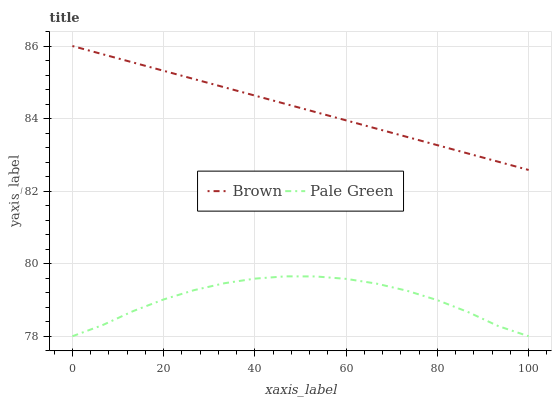Does Pale Green have the minimum area under the curve?
Answer yes or no. Yes. Does Brown have the maximum area under the curve?
Answer yes or no. Yes. Does Pale Green have the maximum area under the curve?
Answer yes or no. No. Is Brown the smoothest?
Answer yes or no. Yes. Is Pale Green the roughest?
Answer yes or no. Yes. Is Pale Green the smoothest?
Answer yes or no. No. Does Pale Green have the lowest value?
Answer yes or no. Yes. Does Brown have the highest value?
Answer yes or no. Yes. Does Pale Green have the highest value?
Answer yes or no. No. Is Pale Green less than Brown?
Answer yes or no. Yes. Is Brown greater than Pale Green?
Answer yes or no. Yes. Does Pale Green intersect Brown?
Answer yes or no. No. 